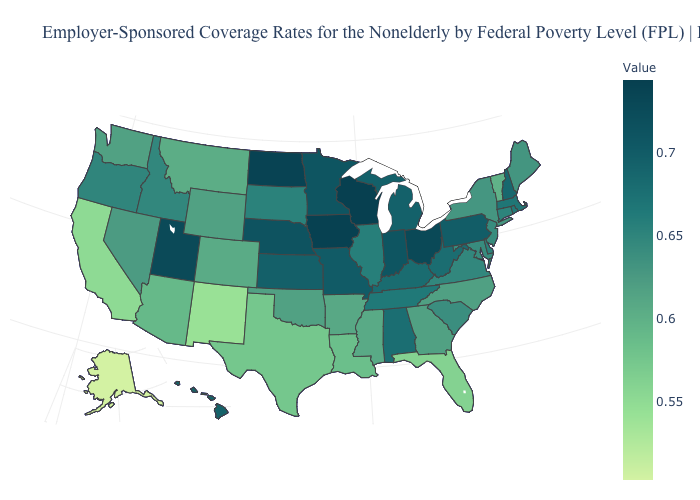Does Delaware have a higher value than Colorado?
Write a very short answer. Yes. Among the states that border Nevada , does Arizona have the lowest value?
Concise answer only. No. Does South Dakota have the lowest value in the MidWest?
Be succinct. Yes. Does Louisiana have a higher value than Oregon?
Give a very brief answer. No. Does Connecticut have a lower value than Indiana?
Short answer required. Yes. 